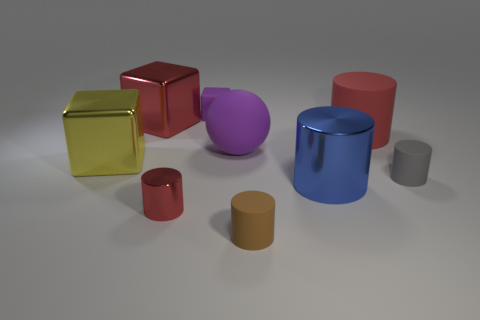There is a big rubber sphere; is its color the same as the rubber object that is behind the big red cylinder?
Provide a succinct answer. Yes. Is the number of big purple things that are in front of the gray rubber cylinder the same as the number of small brown matte things left of the small metallic cylinder?
Offer a very short reply. Yes. What is the material of the red cylinder that is behind the yellow shiny block?
Provide a short and direct response. Rubber. How many objects are either large cubes behind the yellow metallic object or purple matte blocks?
Your response must be concise. 2. What number of other objects are there of the same shape as the tiny red metal thing?
Offer a terse response. 4. Is the shape of the tiny matte object behind the small gray object the same as  the yellow object?
Ensure brevity in your answer.  Yes. There is a tiny gray rubber cylinder; are there any big matte cylinders on the left side of it?
Offer a terse response. Yes. What number of large objects are gray rubber objects or metallic cubes?
Your answer should be compact. 2. Does the small brown cylinder have the same material as the sphere?
Provide a succinct answer. Yes. There is a rubber object that is the same color as the rubber sphere; what size is it?
Give a very brief answer. Small. 